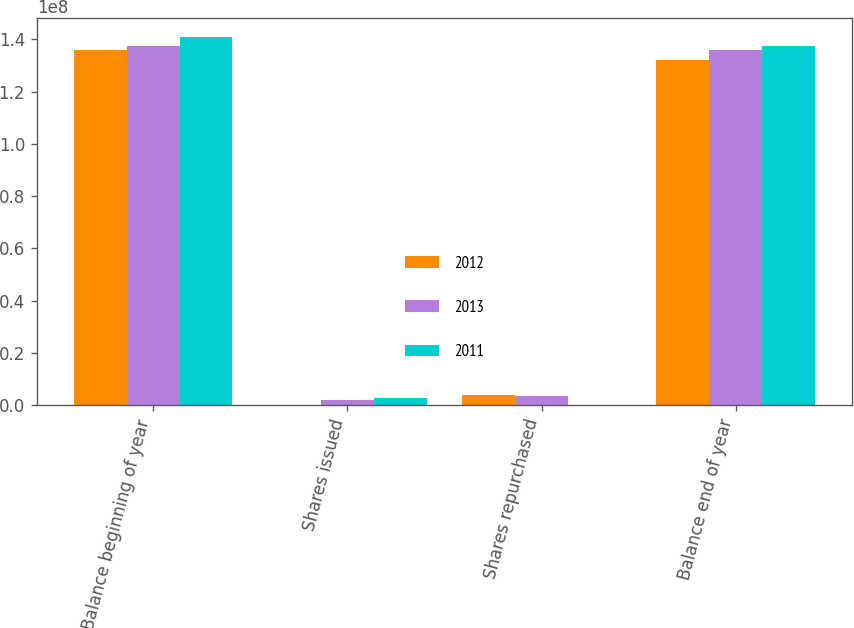Convert chart. <chart><loc_0><loc_0><loc_500><loc_500><stacked_bar_chart><ecel><fcel>Balance beginning of year<fcel>Shares issued<fcel>Shares repurchased<fcel>Balance end of year<nl><fcel>2012<fcel>1.36018e+08<fcel>139790<fcel>3.92436e+06<fcel>1.32233e+08<nl><fcel>2013<fcel>1.3752e+08<fcel>2.11417e+06<fcel>3.61646e+06<fcel>1.36018e+08<nl><fcel>2011<fcel>1.4101e+08<fcel>2.7023e+06<fcel>6192.12<fcel>1.3752e+08<nl></chart> 